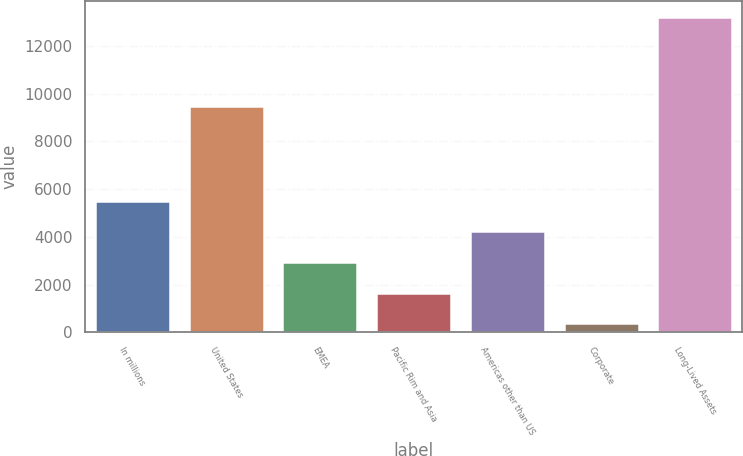<chart> <loc_0><loc_0><loc_500><loc_500><bar_chart><fcel>In millions<fcel>United States<fcel>EMEA<fcel>Pacific Rim and Asia<fcel>Americas other than US<fcel>Corporate<fcel>Long-Lived Assets<nl><fcel>5523.8<fcel>9476<fcel>2953.4<fcel>1668.2<fcel>4238.6<fcel>383<fcel>13235<nl></chart> 